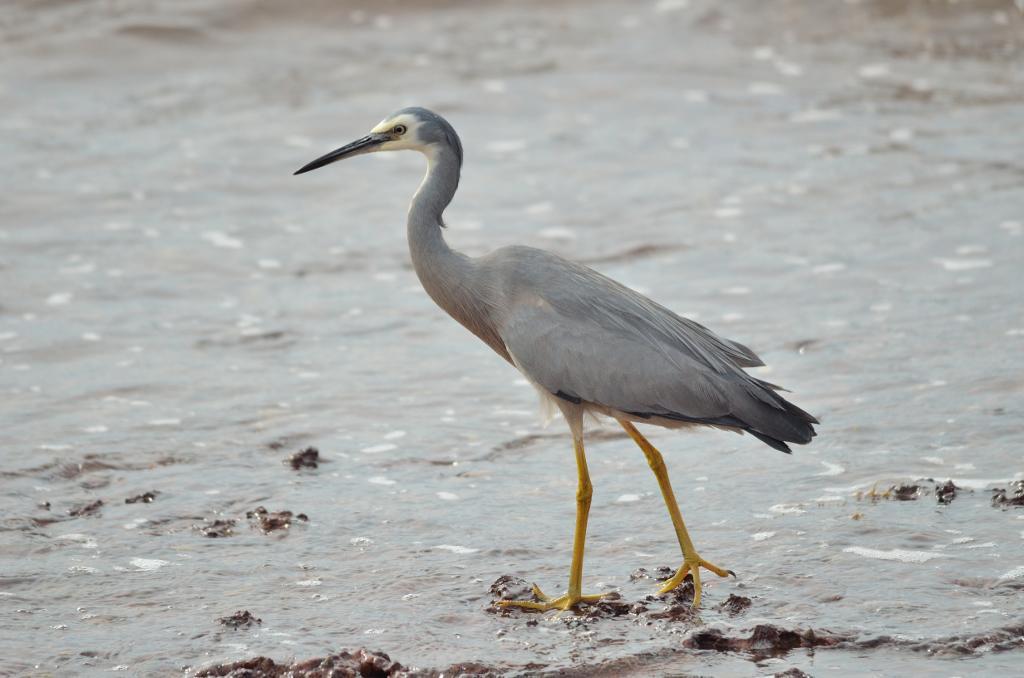In one or two sentences, can you explain what this image depicts? In the front of the image we can see a bird and mud. In the background of the image it is blurry. 